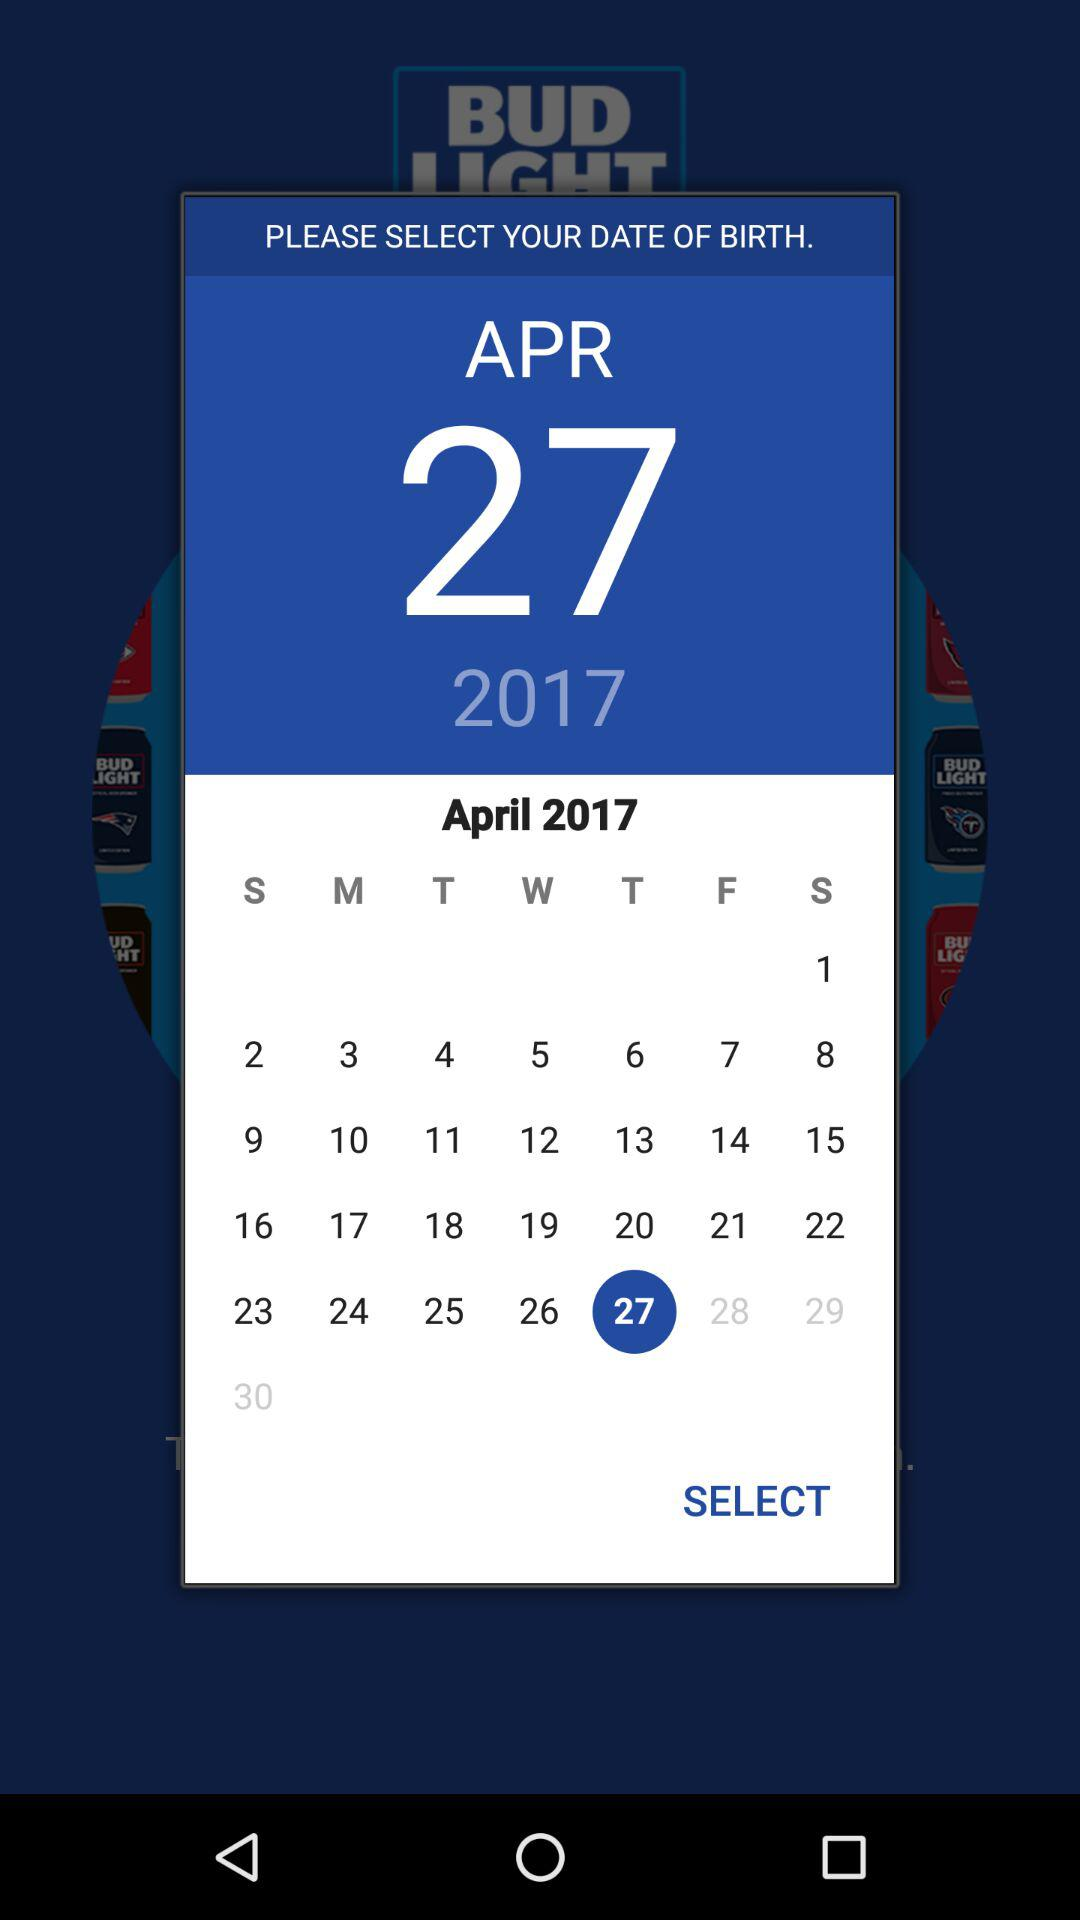How many digits are in the year in the date picker?
Answer the question using a single word or phrase. 4 